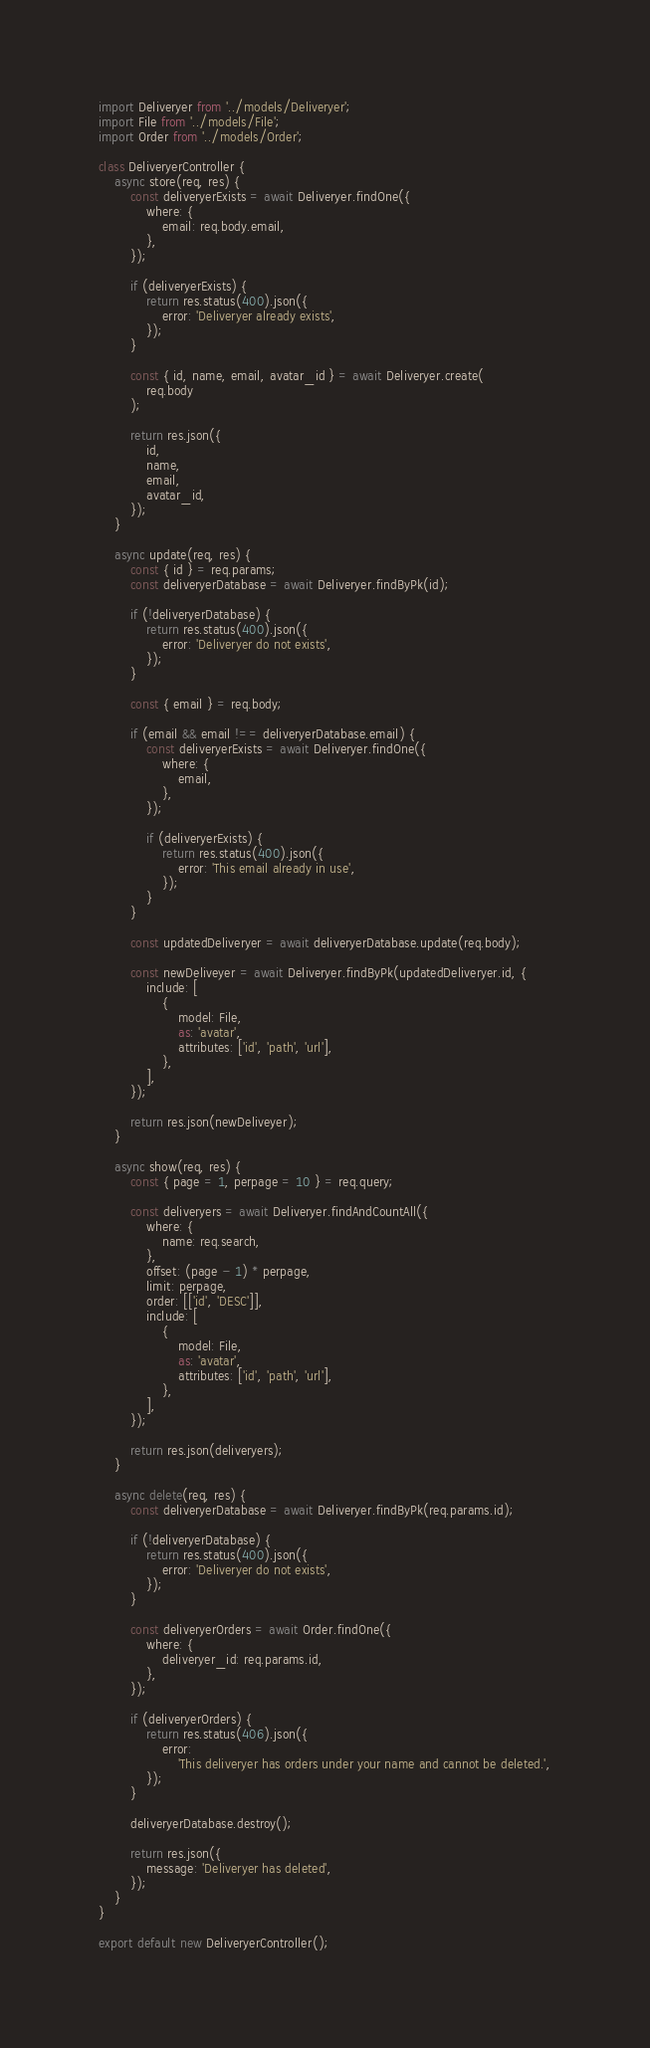Convert code to text. <code><loc_0><loc_0><loc_500><loc_500><_JavaScript_>import Deliveryer from '../models/Deliveryer';
import File from '../models/File';
import Order from '../models/Order';

class DeliveryerController {
    async store(req, res) {
        const deliveryerExists = await Deliveryer.findOne({
            where: {
                email: req.body.email,
            },
        });

        if (deliveryerExists) {
            return res.status(400).json({
                error: 'Deliveryer already exists',
            });
        }

        const { id, name, email, avatar_id } = await Deliveryer.create(
            req.body
        );

        return res.json({
            id,
            name,
            email,
            avatar_id,
        });
    }

    async update(req, res) {
        const { id } = req.params;
        const deliveryerDatabase = await Deliveryer.findByPk(id);

        if (!deliveryerDatabase) {
            return res.status(400).json({
                error: 'Deliveryer do not exists',
            });
        }

        const { email } = req.body;

        if (email && email !== deliveryerDatabase.email) {
            const deliveryerExists = await Deliveryer.findOne({
                where: {
                    email,
                },
            });

            if (deliveryerExists) {
                return res.status(400).json({
                    error: 'This email already in use',
                });
            }
        }

        const updatedDeliveryer = await deliveryerDatabase.update(req.body);

        const newDeliveyer = await Deliveryer.findByPk(updatedDeliveryer.id, {
            include: [
                {
                    model: File,
                    as: 'avatar',
                    attributes: ['id', 'path', 'url'],
                },
            ],
        });

        return res.json(newDeliveyer);
    }

    async show(req, res) {
        const { page = 1, perpage = 10 } = req.query;

        const deliveryers = await Deliveryer.findAndCountAll({
            where: {
                name: req.search,
            },
            offset: (page - 1) * perpage,
            limit: perpage,
            order: [['id', 'DESC']],
            include: [
                {
                    model: File,
                    as: 'avatar',
                    attributes: ['id', 'path', 'url'],
                },
            ],
        });

        return res.json(deliveryers);
    }

    async delete(req, res) {
        const deliveryerDatabase = await Deliveryer.findByPk(req.params.id);

        if (!deliveryerDatabase) {
            return res.status(400).json({
                error: 'Deliveryer do not exists',
            });
        }

        const deliveryerOrders = await Order.findOne({
            where: {
                deliveryer_id: req.params.id,
            },
        });

        if (deliveryerOrders) {
            return res.status(406).json({
                error:
                    'This deliveryer has orders under your name and cannot be deleted.',
            });
        }

        deliveryerDatabase.destroy();

        return res.json({
            message: 'Deliveryer has deleted',
        });
    }
}

export default new DeliveryerController();
</code> 